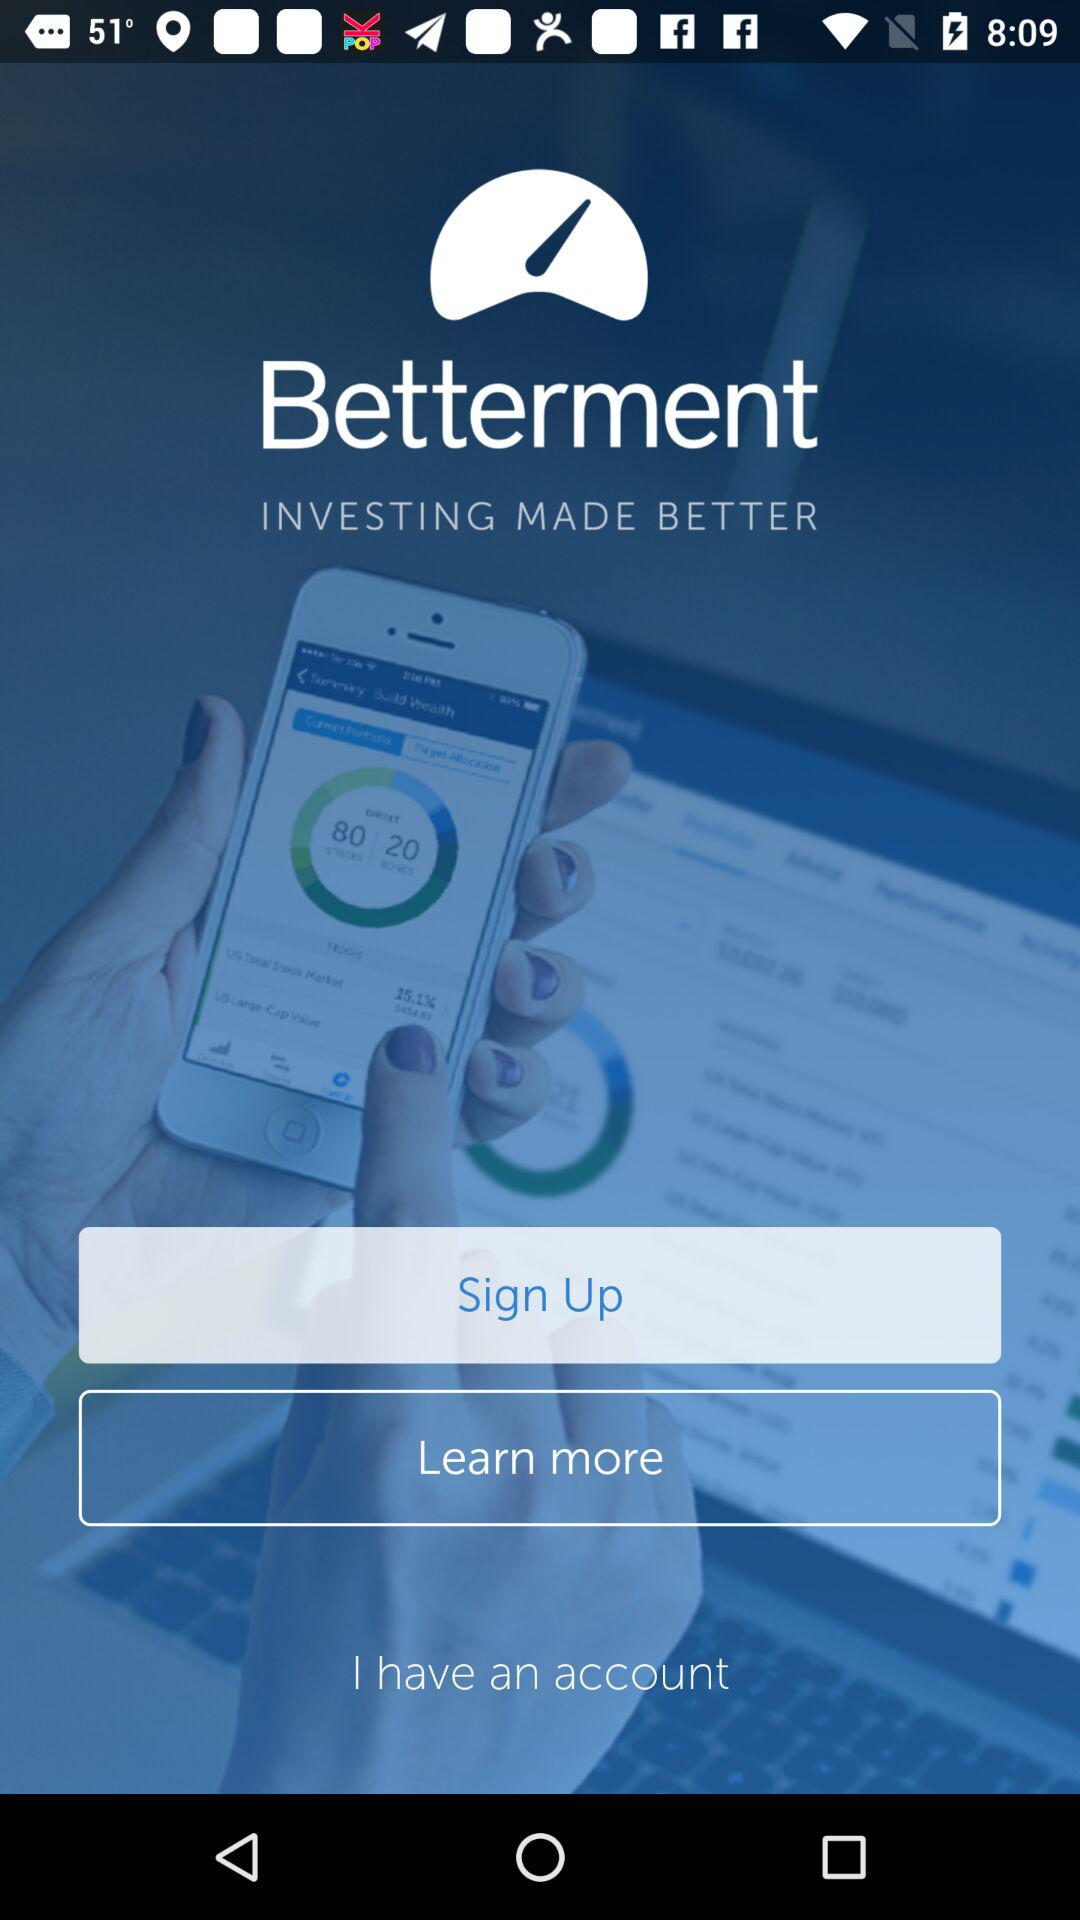What is the name of the application? The name of the application is "Betterment INVESTING MADE BETTER". 